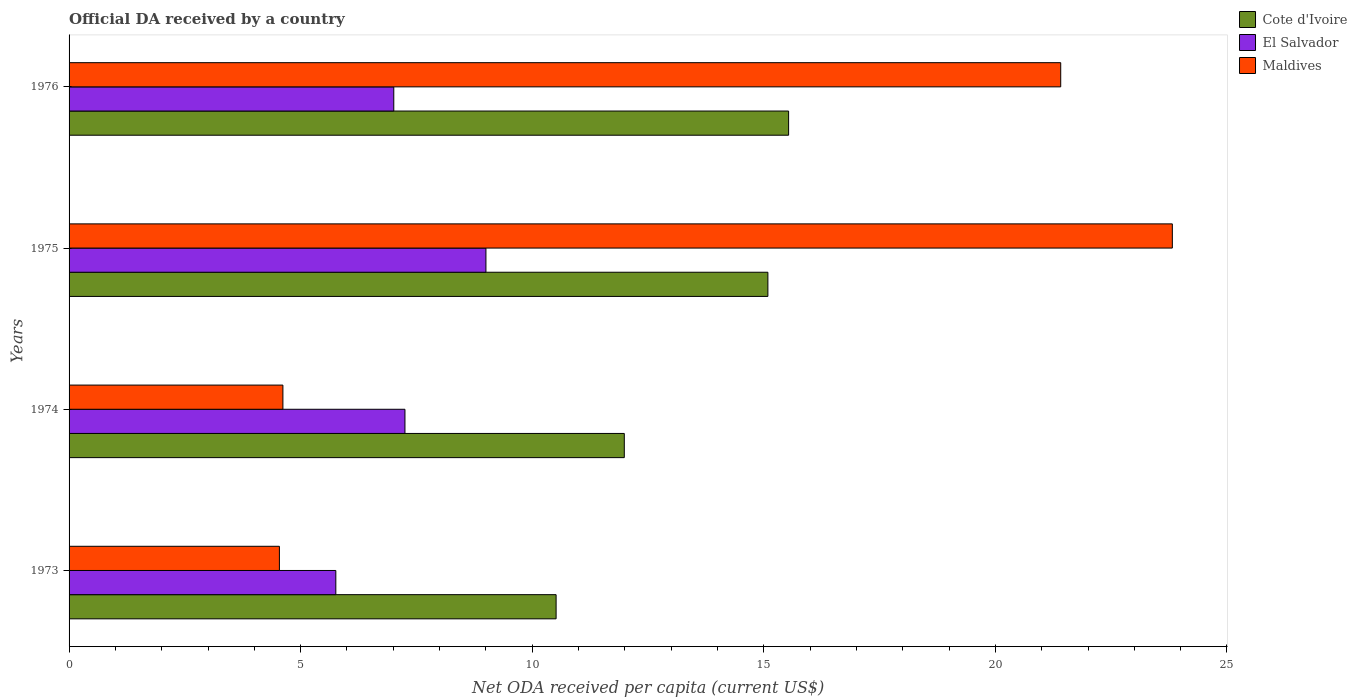How many different coloured bars are there?
Keep it short and to the point. 3. Are the number of bars per tick equal to the number of legend labels?
Provide a short and direct response. Yes. How many bars are there on the 3rd tick from the top?
Ensure brevity in your answer.  3. How many bars are there on the 1st tick from the bottom?
Ensure brevity in your answer.  3. What is the ODA received in in El Salvador in 1974?
Make the answer very short. 7.25. Across all years, what is the maximum ODA received in in El Salvador?
Your answer should be very brief. 9. Across all years, what is the minimum ODA received in in Cote d'Ivoire?
Your answer should be compact. 10.52. In which year was the ODA received in in Cote d'Ivoire maximum?
Make the answer very short. 1976. In which year was the ODA received in in El Salvador minimum?
Give a very brief answer. 1973. What is the total ODA received in in Cote d'Ivoire in the graph?
Provide a short and direct response. 53.13. What is the difference between the ODA received in in El Salvador in 1973 and that in 1976?
Your response must be concise. -1.25. What is the difference between the ODA received in in El Salvador in 1973 and the ODA received in in Cote d'Ivoire in 1975?
Ensure brevity in your answer.  -9.33. What is the average ODA received in in El Salvador per year?
Offer a terse response. 7.26. In the year 1973, what is the difference between the ODA received in in El Salvador and ODA received in in Cote d'Ivoire?
Make the answer very short. -4.76. In how many years, is the ODA received in in El Salvador greater than 7 US$?
Offer a terse response. 3. What is the ratio of the ODA received in in Cote d'Ivoire in 1973 to that in 1975?
Your answer should be very brief. 0.7. Is the difference between the ODA received in in El Salvador in 1973 and 1975 greater than the difference between the ODA received in in Cote d'Ivoire in 1973 and 1975?
Provide a succinct answer. Yes. What is the difference between the highest and the second highest ODA received in in Maldives?
Provide a succinct answer. 2.41. What is the difference between the highest and the lowest ODA received in in El Salvador?
Provide a short and direct response. 3.24. In how many years, is the ODA received in in El Salvador greater than the average ODA received in in El Salvador taken over all years?
Ensure brevity in your answer.  1. What does the 2nd bar from the top in 1973 represents?
Offer a terse response. El Salvador. What does the 2nd bar from the bottom in 1974 represents?
Ensure brevity in your answer.  El Salvador. Is it the case that in every year, the sum of the ODA received in in Maldives and ODA received in in Cote d'Ivoire is greater than the ODA received in in El Salvador?
Give a very brief answer. Yes. Does the graph contain any zero values?
Ensure brevity in your answer.  No. What is the title of the graph?
Your answer should be compact. Official DA received by a country. Does "Paraguay" appear as one of the legend labels in the graph?
Offer a terse response. No. What is the label or title of the X-axis?
Your answer should be compact. Net ODA received per capita (current US$). What is the label or title of the Y-axis?
Make the answer very short. Years. What is the Net ODA received per capita (current US$) of Cote d'Ivoire in 1973?
Your answer should be very brief. 10.52. What is the Net ODA received per capita (current US$) of El Salvador in 1973?
Give a very brief answer. 5.76. What is the Net ODA received per capita (current US$) of Maldives in 1973?
Your answer should be compact. 4.54. What is the Net ODA received per capita (current US$) in Cote d'Ivoire in 1974?
Keep it short and to the point. 11.99. What is the Net ODA received per capita (current US$) of El Salvador in 1974?
Your answer should be very brief. 7.25. What is the Net ODA received per capita (current US$) in Maldives in 1974?
Keep it short and to the point. 4.62. What is the Net ODA received per capita (current US$) of Cote d'Ivoire in 1975?
Your answer should be compact. 15.09. What is the Net ODA received per capita (current US$) of El Salvador in 1975?
Provide a succinct answer. 9. What is the Net ODA received per capita (current US$) in Maldives in 1975?
Make the answer very short. 23.82. What is the Net ODA received per capita (current US$) of Cote d'Ivoire in 1976?
Make the answer very short. 15.54. What is the Net ODA received per capita (current US$) of El Salvador in 1976?
Keep it short and to the point. 7.01. What is the Net ODA received per capita (current US$) in Maldives in 1976?
Your answer should be compact. 21.41. Across all years, what is the maximum Net ODA received per capita (current US$) of Cote d'Ivoire?
Offer a very short reply. 15.54. Across all years, what is the maximum Net ODA received per capita (current US$) in El Salvador?
Provide a short and direct response. 9. Across all years, what is the maximum Net ODA received per capita (current US$) in Maldives?
Your answer should be compact. 23.82. Across all years, what is the minimum Net ODA received per capita (current US$) in Cote d'Ivoire?
Offer a terse response. 10.52. Across all years, what is the minimum Net ODA received per capita (current US$) in El Salvador?
Make the answer very short. 5.76. Across all years, what is the minimum Net ODA received per capita (current US$) of Maldives?
Your response must be concise. 4.54. What is the total Net ODA received per capita (current US$) in Cote d'Ivoire in the graph?
Your answer should be very brief. 53.13. What is the total Net ODA received per capita (current US$) of El Salvador in the graph?
Ensure brevity in your answer.  29.02. What is the total Net ODA received per capita (current US$) in Maldives in the graph?
Your answer should be compact. 54.39. What is the difference between the Net ODA received per capita (current US$) in Cote d'Ivoire in 1973 and that in 1974?
Offer a very short reply. -1.47. What is the difference between the Net ODA received per capita (current US$) of El Salvador in 1973 and that in 1974?
Make the answer very short. -1.49. What is the difference between the Net ODA received per capita (current US$) of Maldives in 1973 and that in 1974?
Offer a very short reply. -0.08. What is the difference between the Net ODA received per capita (current US$) of Cote d'Ivoire in 1973 and that in 1975?
Offer a terse response. -4.57. What is the difference between the Net ODA received per capita (current US$) of El Salvador in 1973 and that in 1975?
Give a very brief answer. -3.24. What is the difference between the Net ODA received per capita (current US$) in Maldives in 1973 and that in 1975?
Make the answer very short. -19.28. What is the difference between the Net ODA received per capita (current US$) in Cote d'Ivoire in 1973 and that in 1976?
Provide a short and direct response. -5.02. What is the difference between the Net ODA received per capita (current US$) in El Salvador in 1973 and that in 1976?
Your response must be concise. -1.25. What is the difference between the Net ODA received per capita (current US$) of Maldives in 1973 and that in 1976?
Your answer should be very brief. -16.87. What is the difference between the Net ODA received per capita (current US$) of Cote d'Ivoire in 1974 and that in 1975?
Provide a short and direct response. -3.1. What is the difference between the Net ODA received per capita (current US$) in El Salvador in 1974 and that in 1975?
Provide a succinct answer. -1.75. What is the difference between the Net ODA received per capita (current US$) of Maldives in 1974 and that in 1975?
Your answer should be compact. -19.2. What is the difference between the Net ODA received per capita (current US$) of Cote d'Ivoire in 1974 and that in 1976?
Offer a terse response. -3.55. What is the difference between the Net ODA received per capita (current US$) in El Salvador in 1974 and that in 1976?
Keep it short and to the point. 0.24. What is the difference between the Net ODA received per capita (current US$) of Maldives in 1974 and that in 1976?
Your response must be concise. -16.79. What is the difference between the Net ODA received per capita (current US$) of Cote d'Ivoire in 1975 and that in 1976?
Provide a succinct answer. -0.45. What is the difference between the Net ODA received per capita (current US$) in El Salvador in 1975 and that in 1976?
Ensure brevity in your answer.  1.99. What is the difference between the Net ODA received per capita (current US$) of Maldives in 1975 and that in 1976?
Offer a terse response. 2.41. What is the difference between the Net ODA received per capita (current US$) in Cote d'Ivoire in 1973 and the Net ODA received per capita (current US$) in El Salvador in 1974?
Provide a succinct answer. 3.26. What is the difference between the Net ODA received per capita (current US$) in Cote d'Ivoire in 1973 and the Net ODA received per capita (current US$) in Maldives in 1974?
Give a very brief answer. 5.9. What is the difference between the Net ODA received per capita (current US$) in El Salvador in 1973 and the Net ODA received per capita (current US$) in Maldives in 1974?
Provide a succinct answer. 1.14. What is the difference between the Net ODA received per capita (current US$) in Cote d'Ivoire in 1973 and the Net ODA received per capita (current US$) in El Salvador in 1975?
Offer a very short reply. 1.52. What is the difference between the Net ODA received per capita (current US$) in Cote d'Ivoire in 1973 and the Net ODA received per capita (current US$) in Maldives in 1975?
Your answer should be very brief. -13.31. What is the difference between the Net ODA received per capita (current US$) in El Salvador in 1973 and the Net ODA received per capita (current US$) in Maldives in 1975?
Provide a succinct answer. -18.06. What is the difference between the Net ODA received per capita (current US$) in Cote d'Ivoire in 1973 and the Net ODA received per capita (current US$) in El Salvador in 1976?
Offer a terse response. 3.51. What is the difference between the Net ODA received per capita (current US$) in Cote d'Ivoire in 1973 and the Net ODA received per capita (current US$) in Maldives in 1976?
Provide a short and direct response. -10.9. What is the difference between the Net ODA received per capita (current US$) of El Salvador in 1973 and the Net ODA received per capita (current US$) of Maldives in 1976?
Make the answer very short. -15.65. What is the difference between the Net ODA received per capita (current US$) of Cote d'Ivoire in 1974 and the Net ODA received per capita (current US$) of El Salvador in 1975?
Give a very brief answer. 2.99. What is the difference between the Net ODA received per capita (current US$) of Cote d'Ivoire in 1974 and the Net ODA received per capita (current US$) of Maldives in 1975?
Your answer should be very brief. -11.83. What is the difference between the Net ODA received per capita (current US$) in El Salvador in 1974 and the Net ODA received per capita (current US$) in Maldives in 1975?
Your response must be concise. -16.57. What is the difference between the Net ODA received per capita (current US$) of Cote d'Ivoire in 1974 and the Net ODA received per capita (current US$) of El Salvador in 1976?
Provide a short and direct response. 4.98. What is the difference between the Net ODA received per capita (current US$) in Cote d'Ivoire in 1974 and the Net ODA received per capita (current US$) in Maldives in 1976?
Ensure brevity in your answer.  -9.42. What is the difference between the Net ODA received per capita (current US$) in El Salvador in 1974 and the Net ODA received per capita (current US$) in Maldives in 1976?
Give a very brief answer. -14.16. What is the difference between the Net ODA received per capita (current US$) of Cote d'Ivoire in 1975 and the Net ODA received per capita (current US$) of El Salvador in 1976?
Ensure brevity in your answer.  8.08. What is the difference between the Net ODA received per capita (current US$) in Cote d'Ivoire in 1975 and the Net ODA received per capita (current US$) in Maldives in 1976?
Offer a very short reply. -6.32. What is the difference between the Net ODA received per capita (current US$) in El Salvador in 1975 and the Net ODA received per capita (current US$) in Maldives in 1976?
Ensure brevity in your answer.  -12.41. What is the average Net ODA received per capita (current US$) of Cote d'Ivoire per year?
Offer a very short reply. 13.28. What is the average Net ODA received per capita (current US$) in El Salvador per year?
Your response must be concise. 7.26. What is the average Net ODA received per capita (current US$) in Maldives per year?
Your answer should be compact. 13.6. In the year 1973, what is the difference between the Net ODA received per capita (current US$) in Cote d'Ivoire and Net ODA received per capita (current US$) in El Salvador?
Provide a succinct answer. 4.76. In the year 1973, what is the difference between the Net ODA received per capita (current US$) in Cote d'Ivoire and Net ODA received per capita (current US$) in Maldives?
Provide a short and direct response. 5.97. In the year 1973, what is the difference between the Net ODA received per capita (current US$) of El Salvador and Net ODA received per capita (current US$) of Maldives?
Give a very brief answer. 1.22. In the year 1974, what is the difference between the Net ODA received per capita (current US$) of Cote d'Ivoire and Net ODA received per capita (current US$) of El Salvador?
Keep it short and to the point. 4.74. In the year 1974, what is the difference between the Net ODA received per capita (current US$) of Cote d'Ivoire and Net ODA received per capita (current US$) of Maldives?
Provide a succinct answer. 7.37. In the year 1974, what is the difference between the Net ODA received per capita (current US$) in El Salvador and Net ODA received per capita (current US$) in Maldives?
Offer a terse response. 2.64. In the year 1975, what is the difference between the Net ODA received per capita (current US$) of Cote d'Ivoire and Net ODA received per capita (current US$) of El Salvador?
Ensure brevity in your answer.  6.09. In the year 1975, what is the difference between the Net ODA received per capita (current US$) in Cote d'Ivoire and Net ODA received per capita (current US$) in Maldives?
Your answer should be compact. -8.73. In the year 1975, what is the difference between the Net ODA received per capita (current US$) of El Salvador and Net ODA received per capita (current US$) of Maldives?
Provide a succinct answer. -14.82. In the year 1976, what is the difference between the Net ODA received per capita (current US$) in Cote d'Ivoire and Net ODA received per capita (current US$) in El Salvador?
Your answer should be very brief. 8.53. In the year 1976, what is the difference between the Net ODA received per capita (current US$) in Cote d'Ivoire and Net ODA received per capita (current US$) in Maldives?
Your answer should be compact. -5.88. In the year 1976, what is the difference between the Net ODA received per capita (current US$) in El Salvador and Net ODA received per capita (current US$) in Maldives?
Your answer should be very brief. -14.4. What is the ratio of the Net ODA received per capita (current US$) of Cote d'Ivoire in 1973 to that in 1974?
Your answer should be very brief. 0.88. What is the ratio of the Net ODA received per capita (current US$) of El Salvador in 1973 to that in 1974?
Provide a short and direct response. 0.79. What is the ratio of the Net ODA received per capita (current US$) of Maldives in 1973 to that in 1974?
Make the answer very short. 0.98. What is the ratio of the Net ODA received per capita (current US$) in Cote d'Ivoire in 1973 to that in 1975?
Provide a short and direct response. 0.7. What is the ratio of the Net ODA received per capita (current US$) of El Salvador in 1973 to that in 1975?
Your answer should be compact. 0.64. What is the ratio of the Net ODA received per capita (current US$) in Maldives in 1973 to that in 1975?
Your answer should be compact. 0.19. What is the ratio of the Net ODA received per capita (current US$) of Cote d'Ivoire in 1973 to that in 1976?
Offer a very short reply. 0.68. What is the ratio of the Net ODA received per capita (current US$) in El Salvador in 1973 to that in 1976?
Provide a short and direct response. 0.82. What is the ratio of the Net ODA received per capita (current US$) in Maldives in 1973 to that in 1976?
Provide a succinct answer. 0.21. What is the ratio of the Net ODA received per capita (current US$) of Cote d'Ivoire in 1974 to that in 1975?
Offer a terse response. 0.79. What is the ratio of the Net ODA received per capita (current US$) of El Salvador in 1974 to that in 1975?
Provide a succinct answer. 0.81. What is the ratio of the Net ODA received per capita (current US$) of Maldives in 1974 to that in 1975?
Your response must be concise. 0.19. What is the ratio of the Net ODA received per capita (current US$) of Cote d'Ivoire in 1974 to that in 1976?
Your answer should be compact. 0.77. What is the ratio of the Net ODA received per capita (current US$) of El Salvador in 1974 to that in 1976?
Keep it short and to the point. 1.03. What is the ratio of the Net ODA received per capita (current US$) of Maldives in 1974 to that in 1976?
Give a very brief answer. 0.22. What is the ratio of the Net ODA received per capita (current US$) of Cote d'Ivoire in 1975 to that in 1976?
Keep it short and to the point. 0.97. What is the ratio of the Net ODA received per capita (current US$) of El Salvador in 1975 to that in 1976?
Give a very brief answer. 1.28. What is the ratio of the Net ODA received per capita (current US$) of Maldives in 1975 to that in 1976?
Keep it short and to the point. 1.11. What is the difference between the highest and the second highest Net ODA received per capita (current US$) in Cote d'Ivoire?
Offer a terse response. 0.45. What is the difference between the highest and the second highest Net ODA received per capita (current US$) in El Salvador?
Provide a short and direct response. 1.75. What is the difference between the highest and the second highest Net ODA received per capita (current US$) in Maldives?
Your answer should be compact. 2.41. What is the difference between the highest and the lowest Net ODA received per capita (current US$) in Cote d'Ivoire?
Make the answer very short. 5.02. What is the difference between the highest and the lowest Net ODA received per capita (current US$) in El Salvador?
Offer a terse response. 3.24. What is the difference between the highest and the lowest Net ODA received per capita (current US$) of Maldives?
Ensure brevity in your answer.  19.28. 